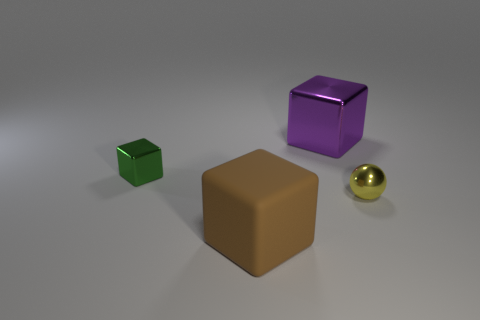What material is the small green object that is the same shape as the big brown thing?
Make the answer very short. Metal. There is a large object on the right side of the big object on the left side of the big thing that is behind the large brown matte thing; what shape is it?
Keep it short and to the point. Cube. How many other things are the same shape as the green metal object?
Ensure brevity in your answer.  2. What number of large purple metallic things are there?
Provide a short and direct response. 1. How many things are green metallic blocks or big matte cylinders?
Your answer should be very brief. 1. There is a large rubber thing; are there any purple shiny things behind it?
Your answer should be very brief. Yes. Are there more small objects that are on the left side of the large brown thing than tiny yellow things behind the tiny yellow shiny ball?
Keep it short and to the point. Yes. There is another purple object that is the same shape as the big rubber object; what size is it?
Offer a terse response. Large. What number of cylinders are purple metallic things or tiny green shiny objects?
Make the answer very short. 0. Are there fewer brown cubes behind the metallic ball than rubber objects that are behind the small green cube?
Make the answer very short. No. 